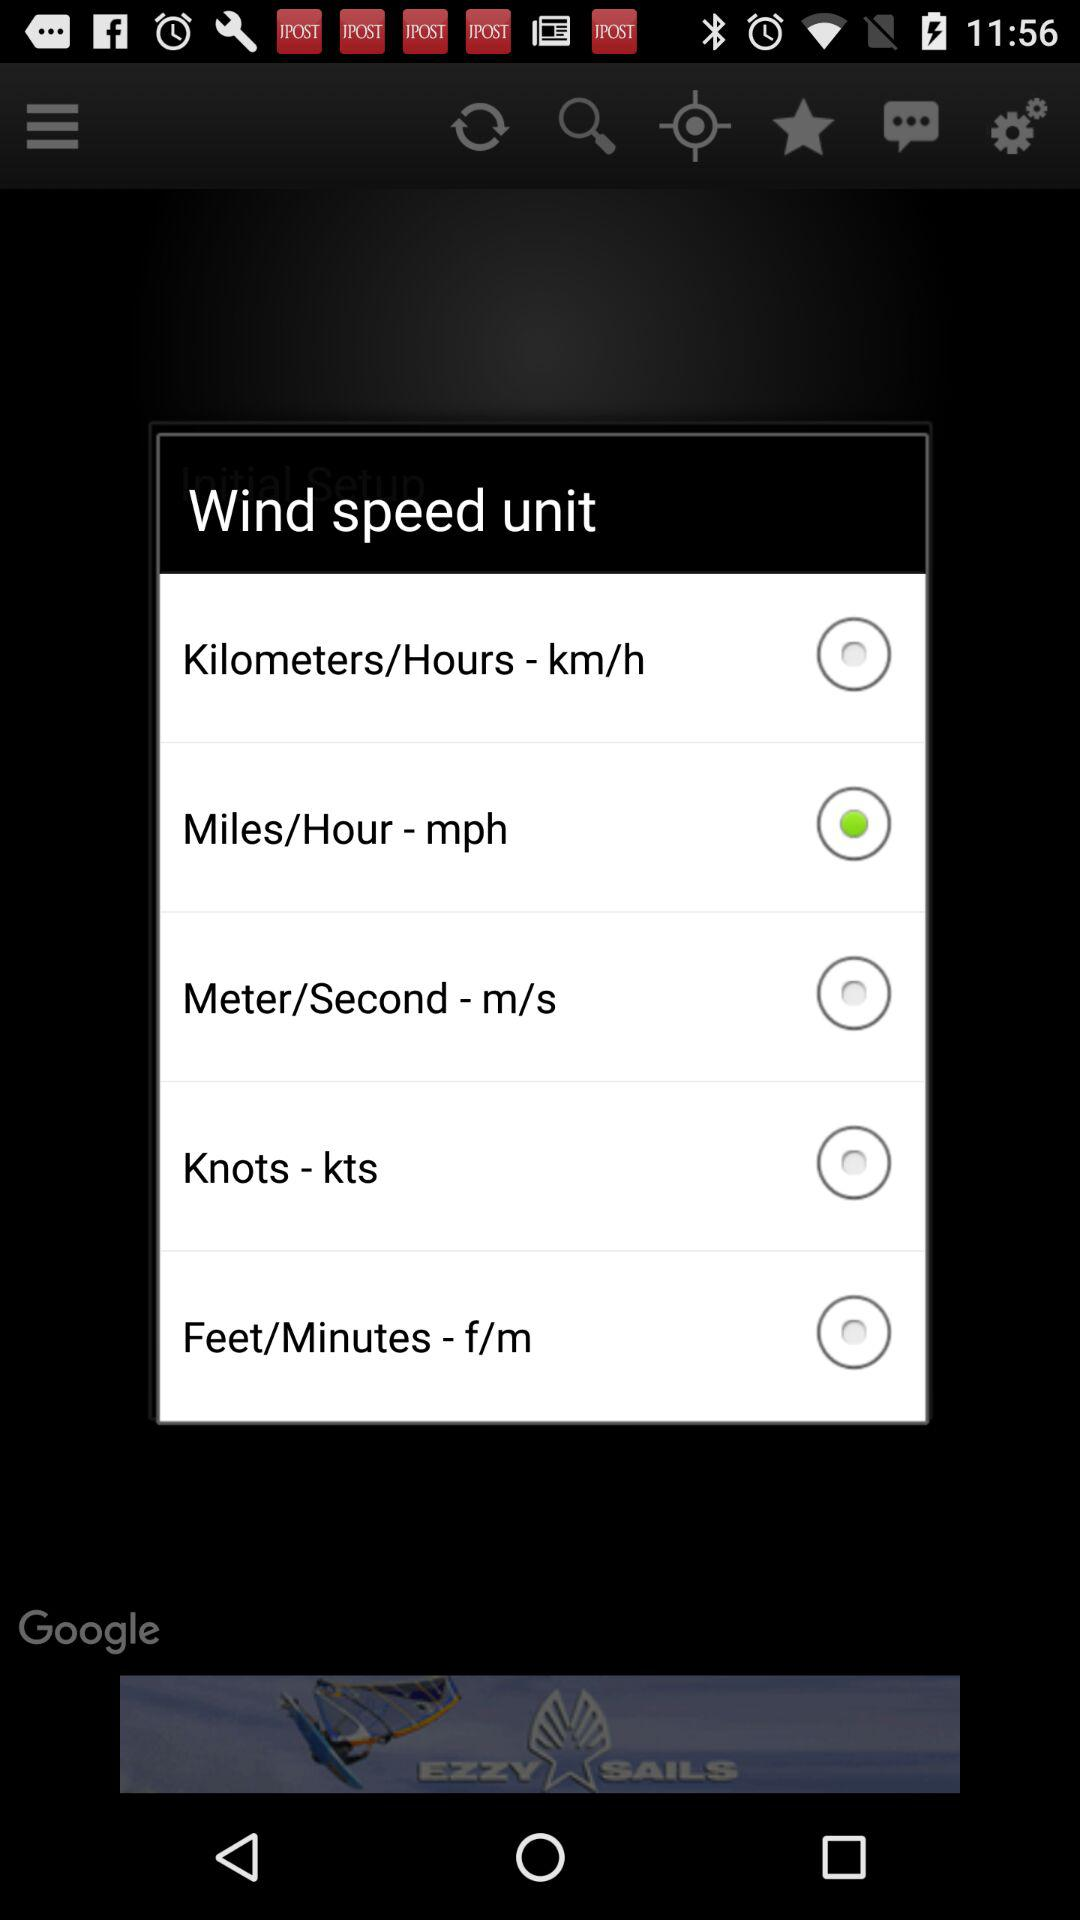Which is the selected unit of wind speed? The selected unit is "Miles/Hour - mph". 